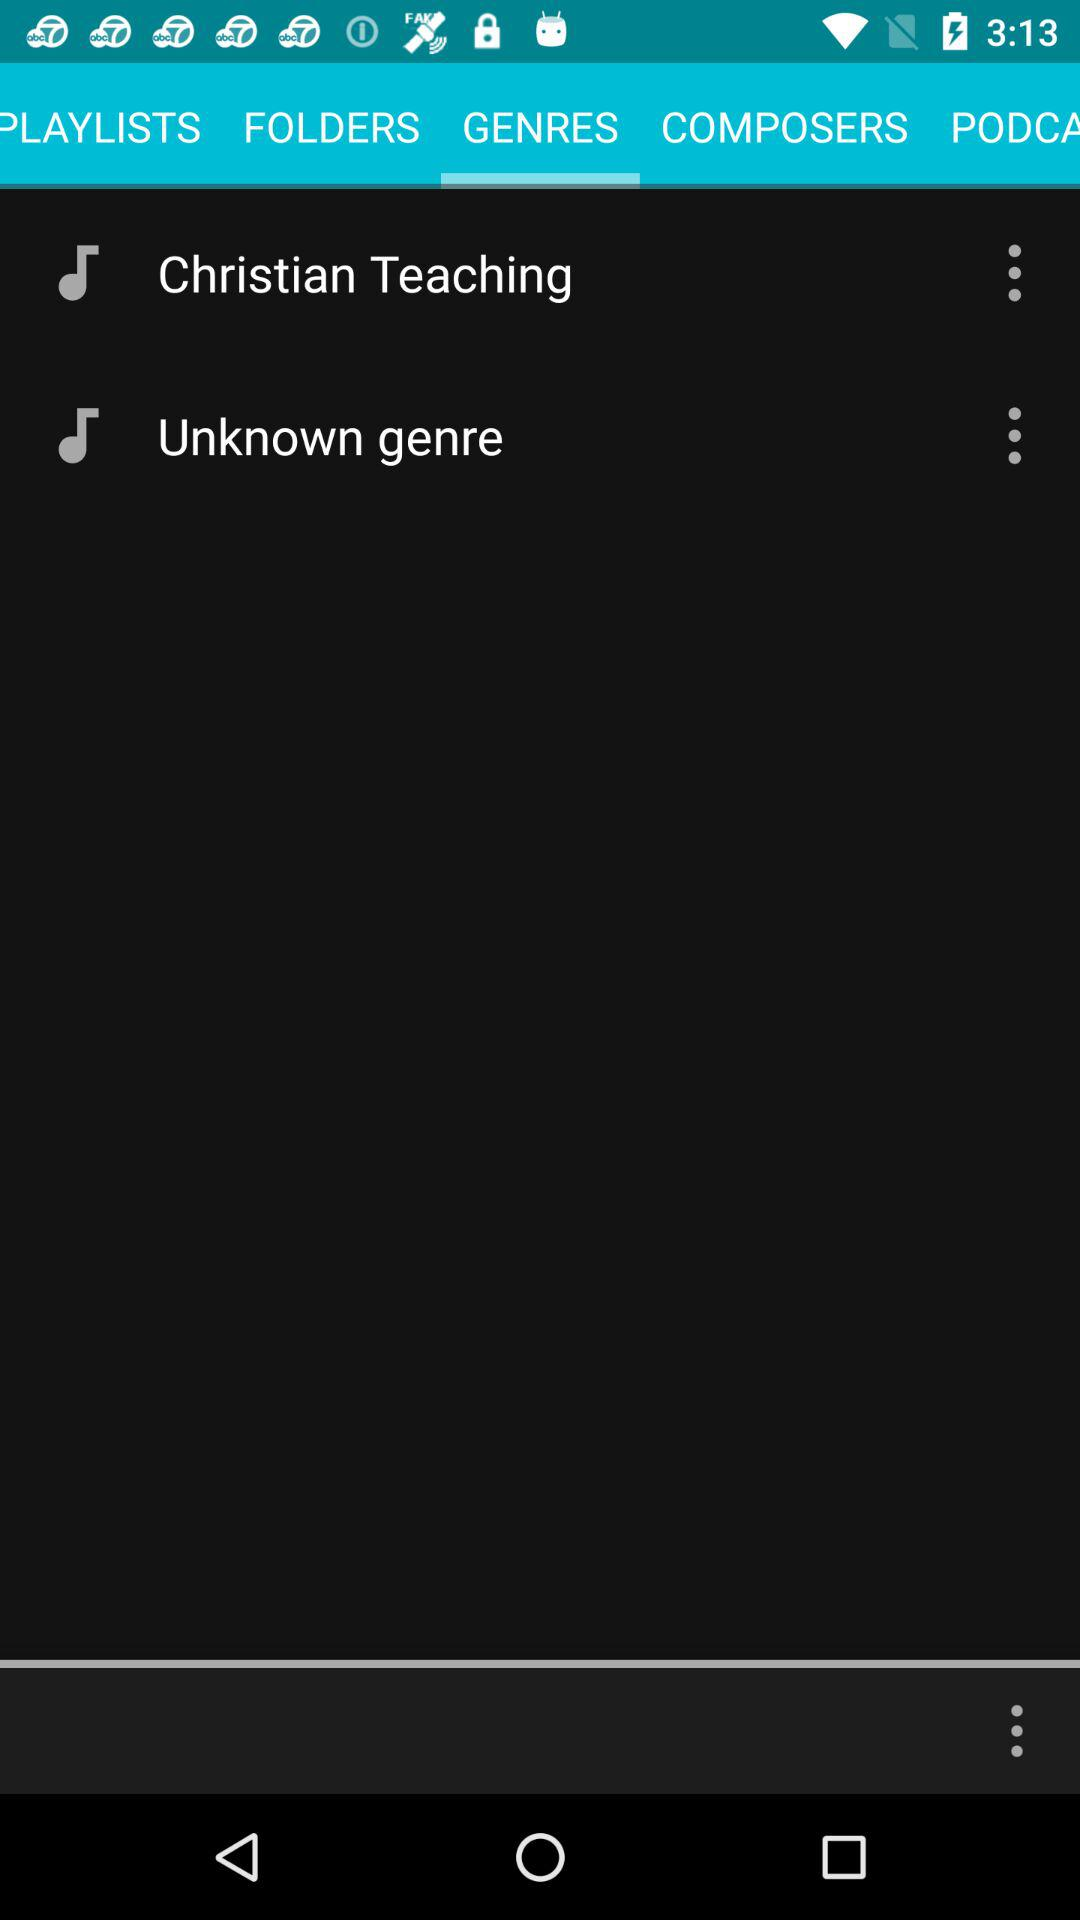How many items have three dots?
Answer the question using a single word or phrase. 2 